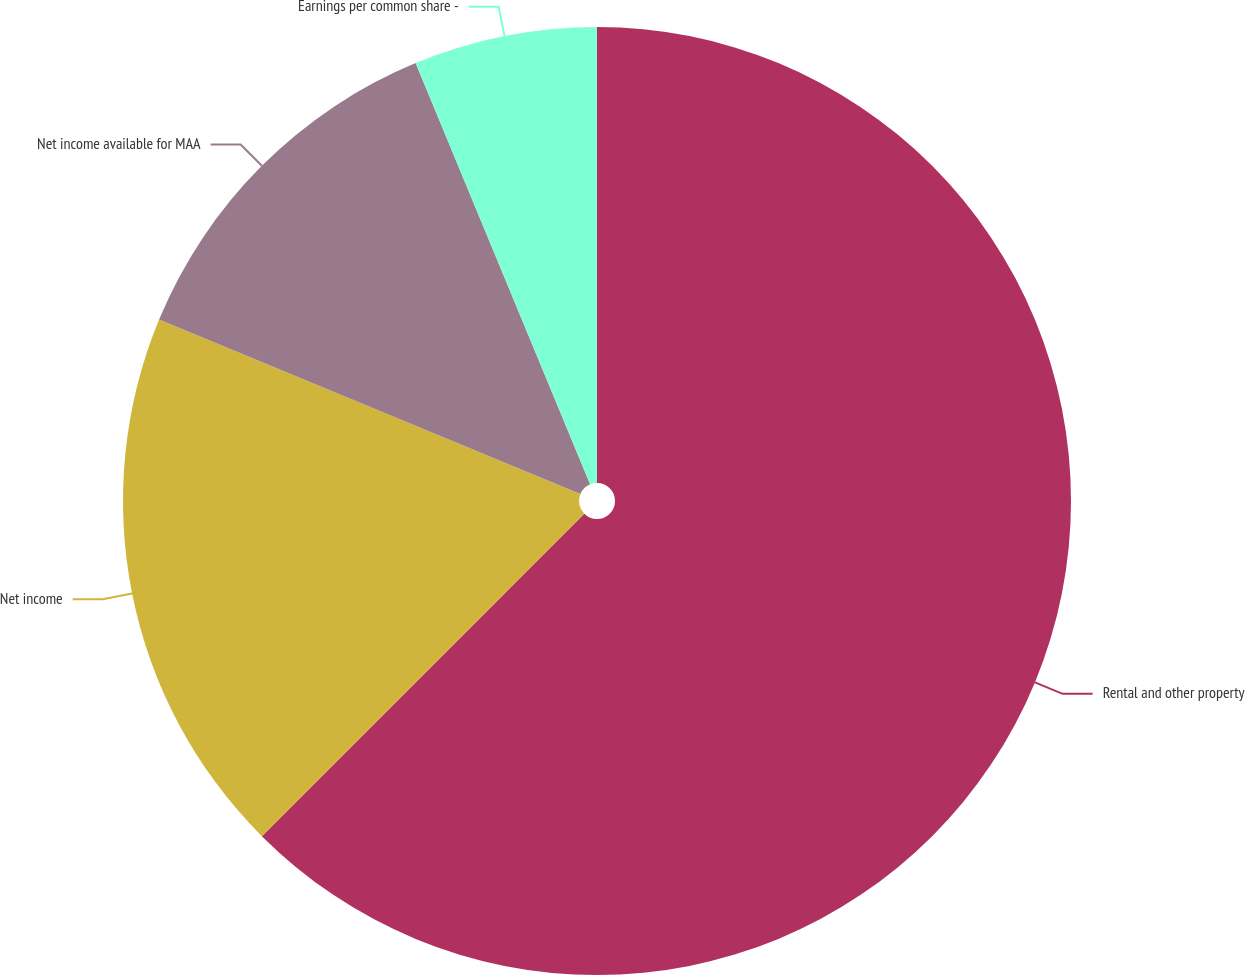<chart> <loc_0><loc_0><loc_500><loc_500><pie_chart><fcel>Rental and other property<fcel>Net income<fcel>Net income available for MAA<fcel>Earnings per common share -<nl><fcel>62.5%<fcel>18.75%<fcel>12.5%<fcel>6.25%<nl></chart> 